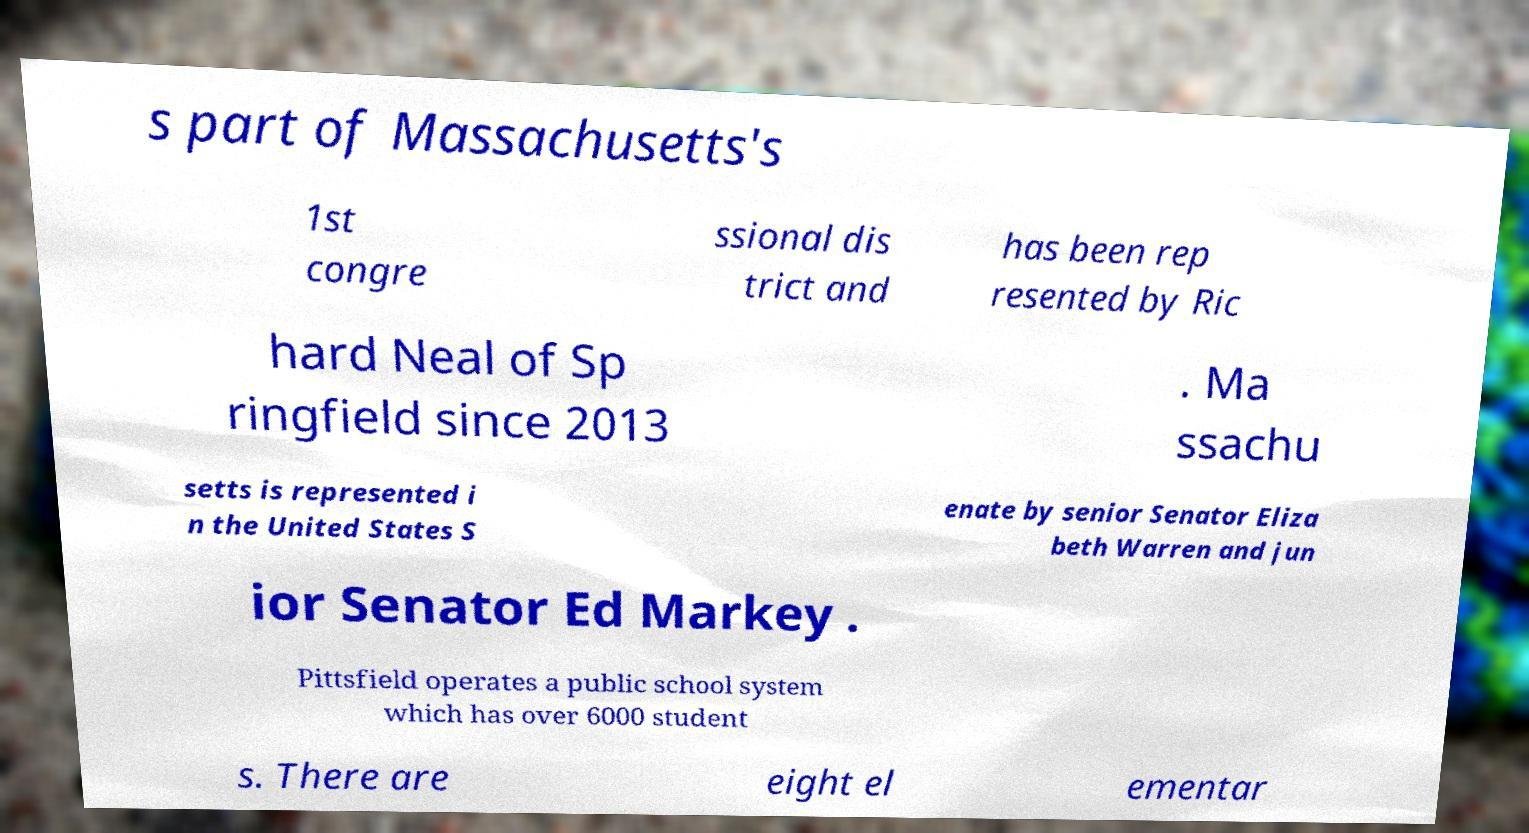Could you extract and type out the text from this image? s part of Massachusetts's 1st congre ssional dis trict and has been rep resented by Ric hard Neal of Sp ringfield since 2013 . Ma ssachu setts is represented i n the United States S enate by senior Senator Eliza beth Warren and jun ior Senator Ed Markey . Pittsfield operates a public school system which has over 6000 student s. There are eight el ementar 